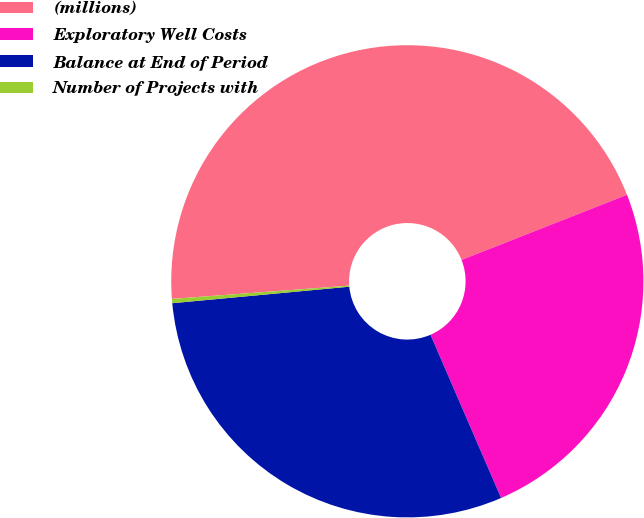Convert chart. <chart><loc_0><loc_0><loc_500><loc_500><pie_chart><fcel>(millions)<fcel>Exploratory Well Costs<fcel>Balance at End of Period<fcel>Number of Projects with<nl><fcel>45.22%<fcel>24.47%<fcel>30.02%<fcel>0.29%<nl></chart> 